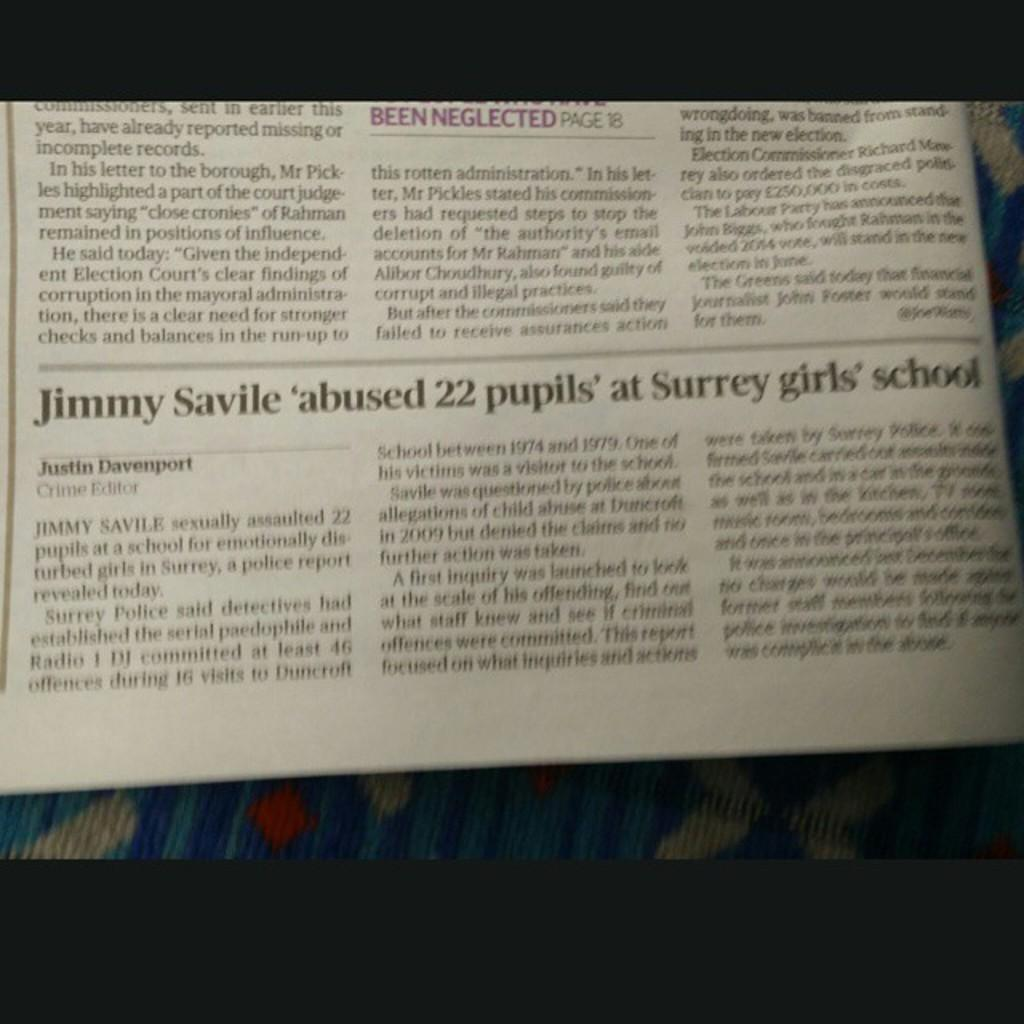What object can be seen in the image? There is a newspaper in the image. What is featured on the newspaper? There is text on the newspaper. Can you see a mark on the mountain in the image? There is no mountain present in the image, and therefore no mark can be seen on it. 